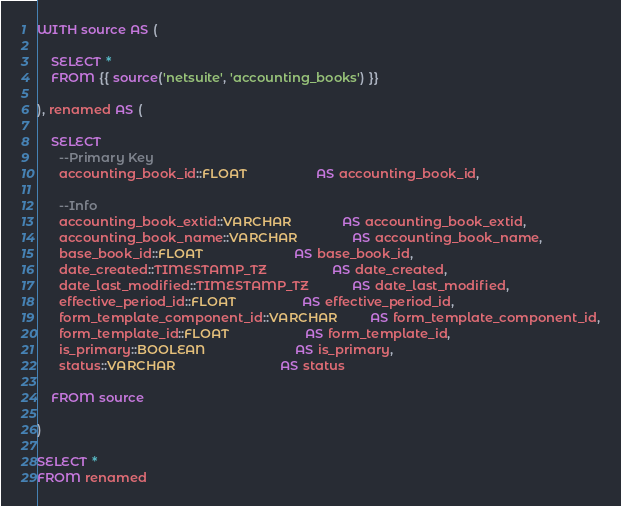Convert code to text. <code><loc_0><loc_0><loc_500><loc_500><_SQL_>WITH source AS (

    SELECT *
    FROM {{ source('netsuite', 'accounting_books') }}

), renamed AS (

    SELECT
      --Primary Key
      accounting_book_id::FLOAT                   AS accounting_book_id,

      --Info
      accounting_book_extid::VARCHAR              AS accounting_book_extid,
      accounting_book_name::VARCHAR               AS accounting_book_name,
      base_book_id::FLOAT                         AS base_book_id,
      date_created::TIMESTAMP_TZ                  AS date_created,
      date_last_modified::TIMESTAMP_TZ            AS date_last_modified,
      effective_period_id::FLOAT                  AS effective_period_id,
      form_template_component_id::VARCHAR         AS form_template_component_id,
      form_template_id::FLOAT                     AS form_template_id,
      is_primary::BOOLEAN                         AS is_primary,
      status::VARCHAR                             AS status

    FROM source

)

SELECT *
FROM renamed
</code> 